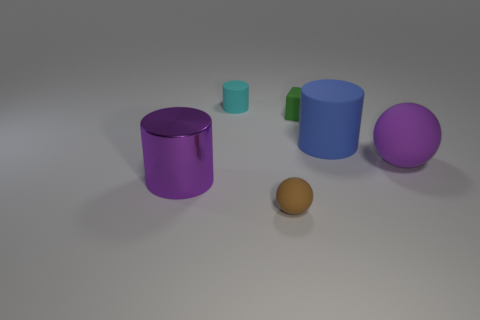Add 3 brown spheres. How many objects exist? 9 Subtract all balls. How many objects are left? 4 Subtract all metallic objects. Subtract all brown spheres. How many objects are left? 4 Add 1 matte cylinders. How many matte cylinders are left? 3 Add 2 small cyan things. How many small cyan things exist? 3 Subtract 0 green cylinders. How many objects are left? 6 